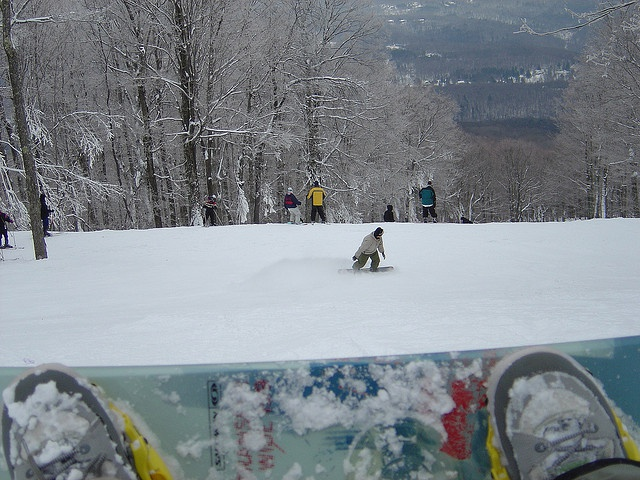Describe the objects in this image and their specific colors. I can see snowboard in gray, darkgray, and blue tones, people in gray, darkgray, and black tones, people in gray and black tones, people in gray, black, olive, and tan tones, and people in gray, black, blue, and darkblue tones in this image. 